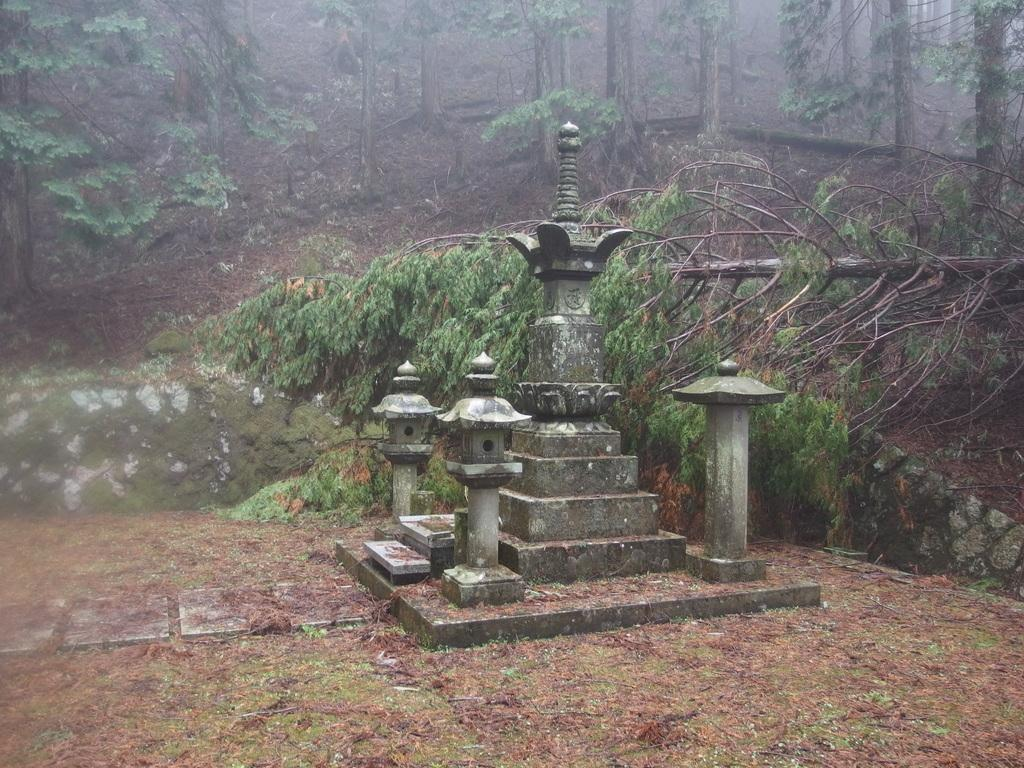What type of natural elements can be seen in the image? There are trees in the image. What might the image be depicting? The image appears to depict a memorial. Can you describe any specific features of the trees in the image? There is a fallen tree in the image. What type of books can be found in the library depicted in the image? There is no library present in the image; it features trees and a fallen tree. How does the ground appear to be expanding in the image? The ground does not appear to be expanding in the image; there is no indication of any ground movement. 